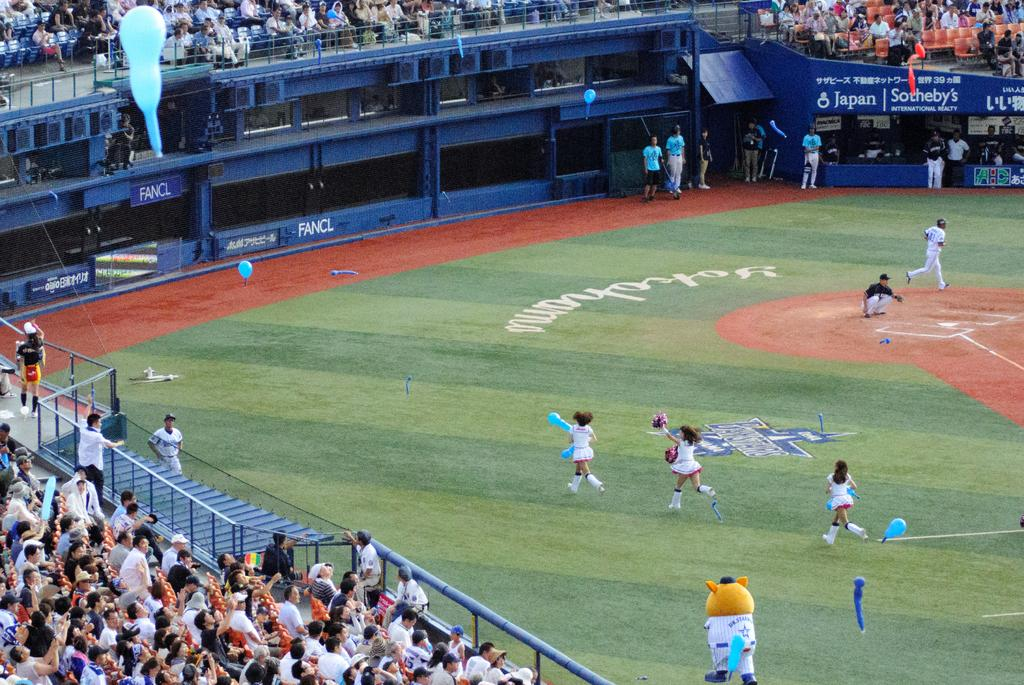<image>
Give a short and clear explanation of the subsequent image. Cheerleaders are running across a field during a baseball game towards a blue wall that says FANCL on it. 